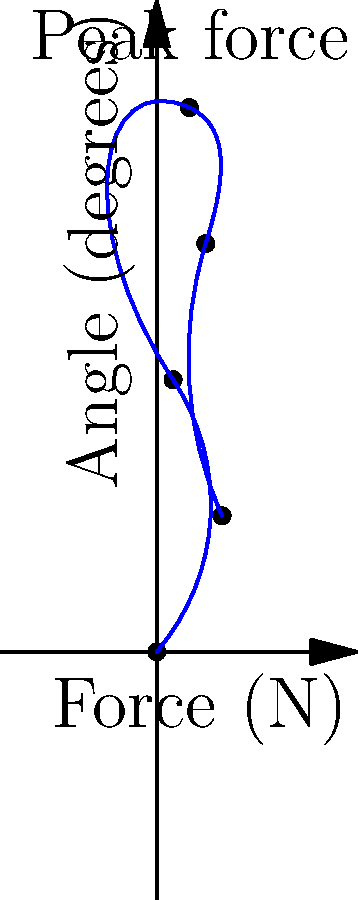The graph shows the force distribution in a prosthetic knee joint during a single gait cycle. What is the approximate peak force experienced by the joint, and at what angle of flexion does this occur? To answer this question, we need to analyze the given force-angle graph for the prosthetic knee joint:

1. The x-axis represents the knee flexion angle in degrees, ranging from 0° to 120°.
2. The y-axis represents the force experienced by the joint in Newtons (N).
3. The blue curve shows the relationship between force and flexion angle during a gait cycle.

To find the peak force and corresponding angle:

1. Examine the curve to locate its highest point.
2. The highest point on the curve represents the peak force.
3. From the graph, we can see that the peak occurs at approximately 60° of knee flexion.
4. The corresponding force at this peak is about 1000 N.

Therefore, the prosthetic knee joint experiences a peak force of approximately 1000 N at a flexion angle of about 60°.

This information is crucial for biomedical engineers designing prosthetic knee joints, as it helps determine the required strength and durability of the joint to withstand the maximum forces experienced during normal walking.
Answer: 1000 N at 60° flexion 